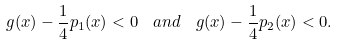Convert formula to latex. <formula><loc_0><loc_0><loc_500><loc_500>g ( x ) - \frac { 1 } { 4 } p _ { 1 } ( x ) < 0 \ \ a n d \ \ g ( x ) - \frac { 1 } { 4 } p _ { 2 } ( x ) < 0 .</formula> 